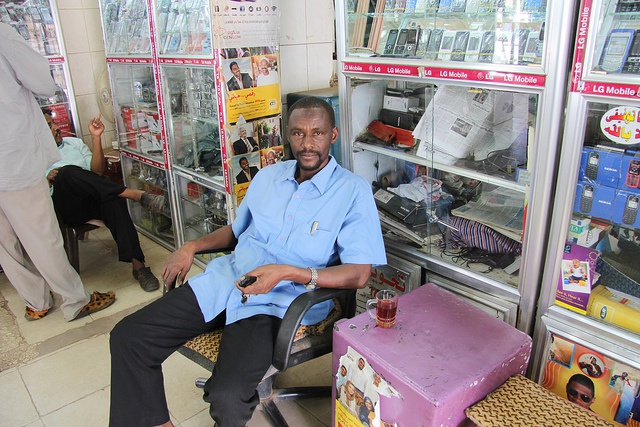Describe the objects in this image and their specific colors. I can see people in purple, black, lightblue, and gray tones, people in purple, darkgray, and gray tones, people in purple, black, maroon, brown, and lightblue tones, chair in purple, black, gray, and darkgray tones, and cup in purple, maroon, brown, gray, and darkgray tones in this image. 